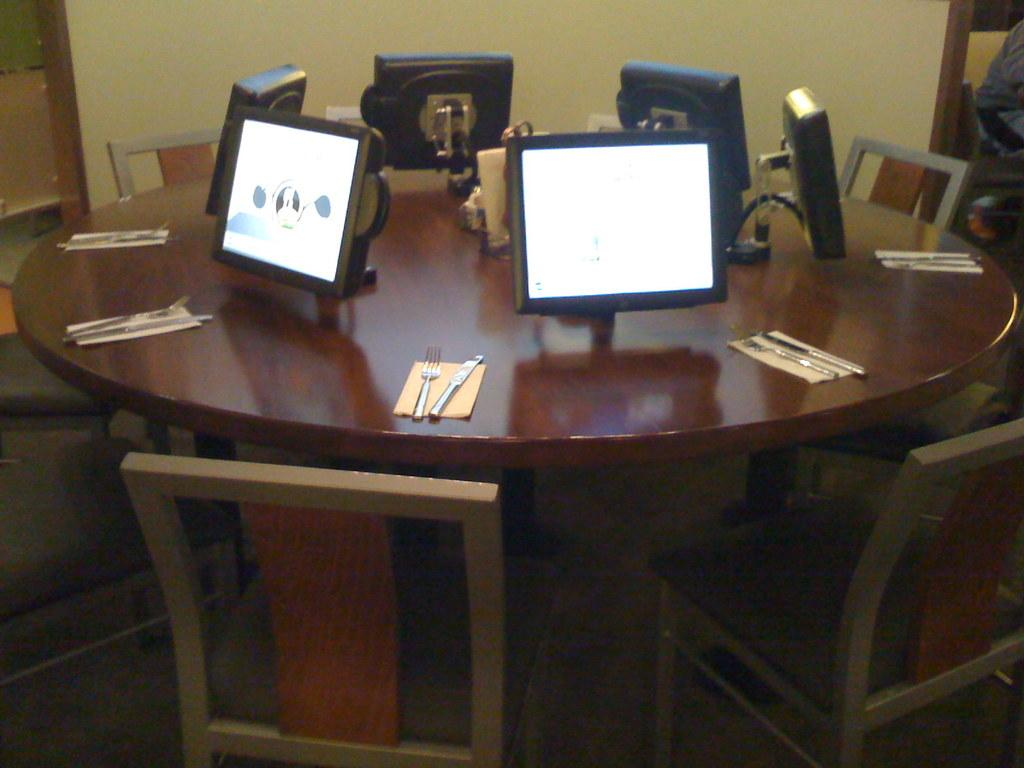What is the main object in the center of the image? There is a table in the center of the image. What is placed around the table? Chairs are placed around the table. What items can be found on the table? The table contains knives, forks, and monitors. What type of locket is hanging from the chair in the image? There is no locket hanging from the chair in the image. In which direction are the chairs facing in the image? The chairs are not facing any specific direction in the image, as they are placed around the table. 